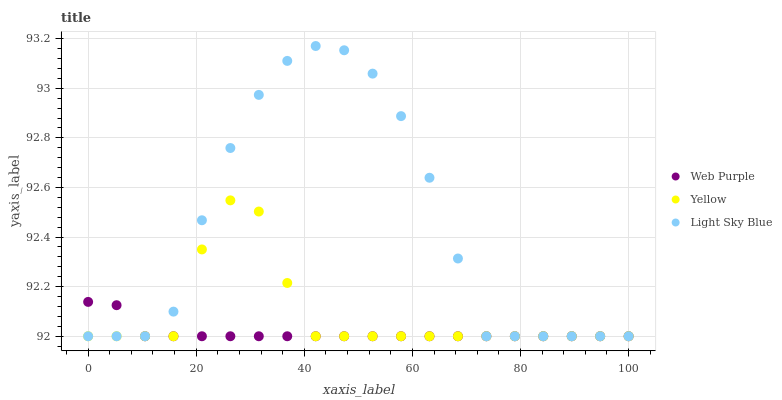Does Web Purple have the minimum area under the curve?
Answer yes or no. Yes. Does Light Sky Blue have the maximum area under the curve?
Answer yes or no. Yes. Does Yellow have the minimum area under the curve?
Answer yes or no. No. Does Yellow have the maximum area under the curve?
Answer yes or no. No. Is Web Purple the smoothest?
Answer yes or no. Yes. Is Light Sky Blue the roughest?
Answer yes or no. Yes. Is Yellow the smoothest?
Answer yes or no. No. Is Yellow the roughest?
Answer yes or no. No. Does Web Purple have the lowest value?
Answer yes or no. Yes. Does Light Sky Blue have the highest value?
Answer yes or no. Yes. Does Yellow have the highest value?
Answer yes or no. No. Does Yellow intersect Web Purple?
Answer yes or no. Yes. Is Yellow less than Web Purple?
Answer yes or no. No. Is Yellow greater than Web Purple?
Answer yes or no. No. 